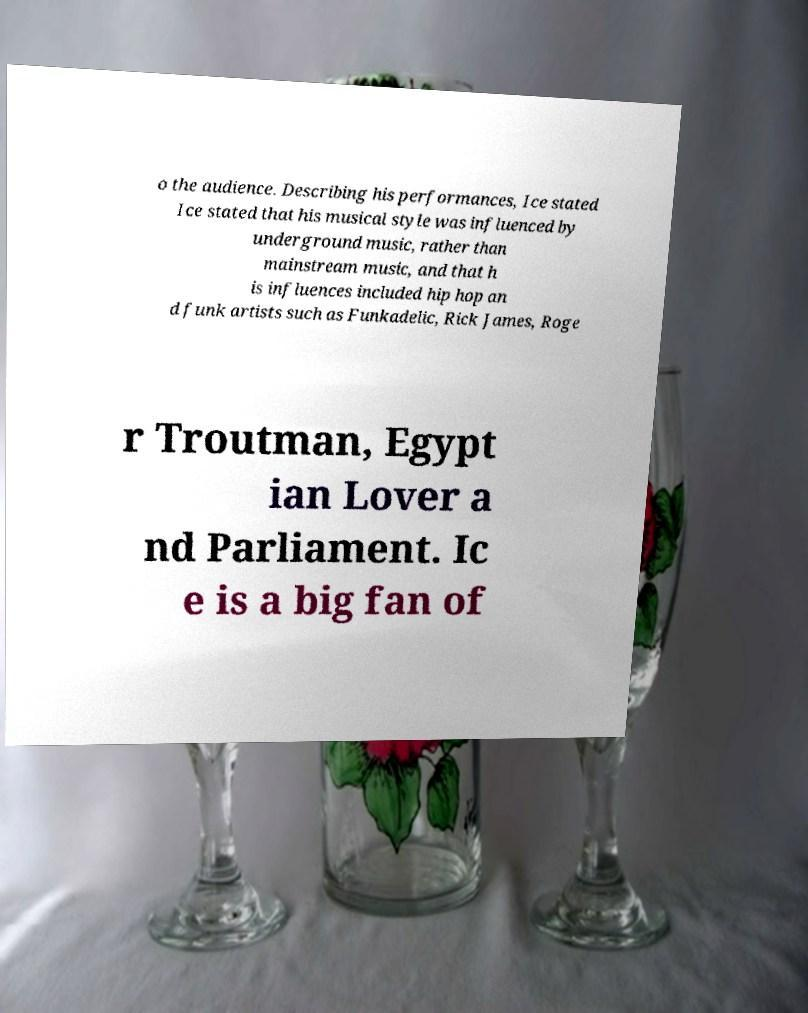Can you accurately transcribe the text from the provided image for me? o the audience. Describing his performances, Ice stated Ice stated that his musical style was influenced by underground music, rather than mainstream music, and that h is influences included hip hop an d funk artists such as Funkadelic, Rick James, Roge r Troutman, Egypt ian Lover a nd Parliament. Ic e is a big fan of 